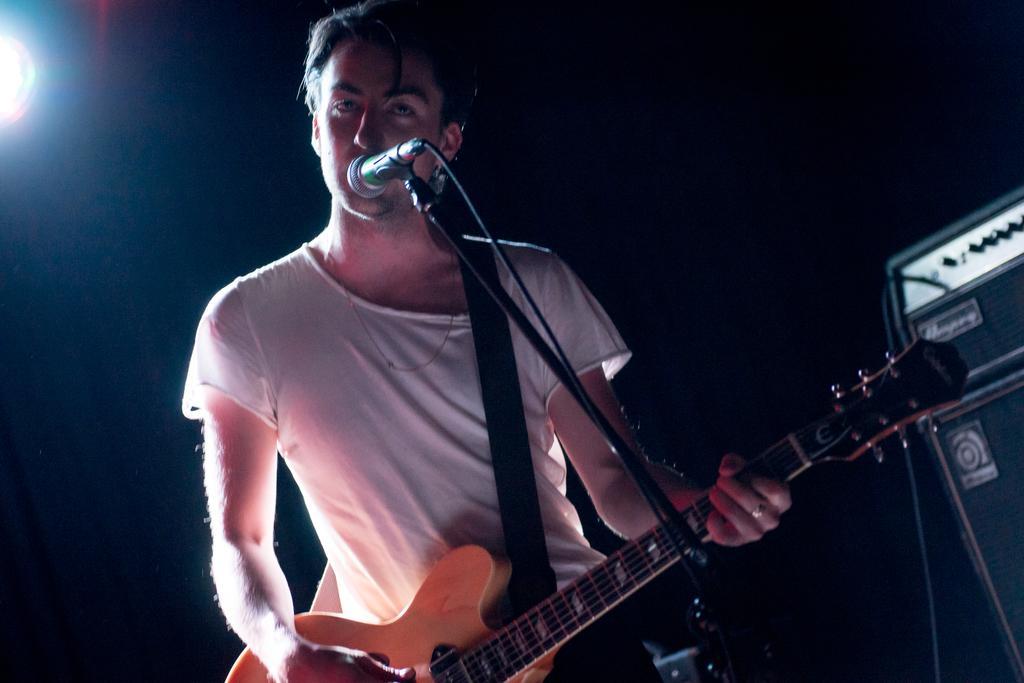Describe this image in one or two sentences. In this image we can see one person standing, playing guitar and singing a song. There is one microphone with stand, one light, one object on the surface, one wire, one object on the surface. 